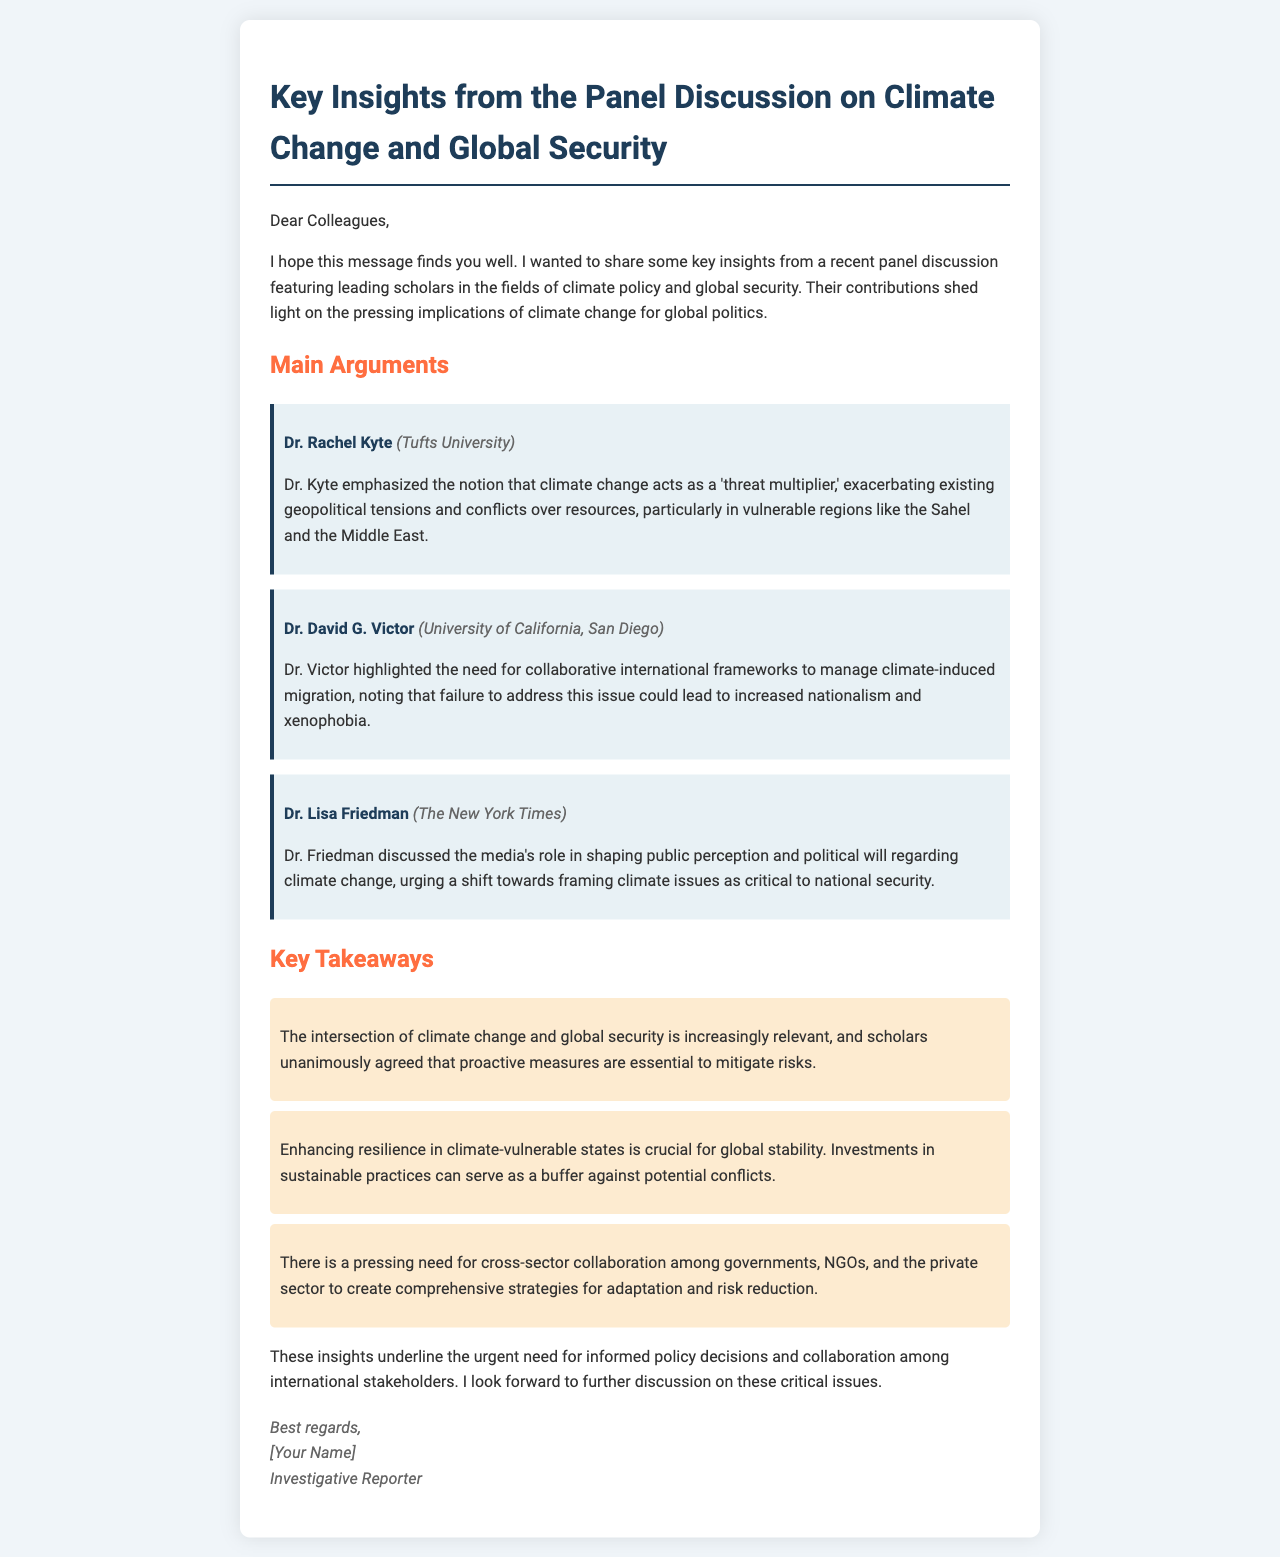What is the title of the panel discussion summary? The title is presented at the beginning of the email, summarizing the key insights from the discussion.
Answer: Key Insights from the Panel Discussion on Climate Change and Global Security Who is the first scholar mentioned in the email? The email lists the scholars in the main arguments section, starting with Dr. Rachel Kyte.
Answer: Dr. Rachel Kyte What is the institution affiliated with Dr. David G. Victor? The email provides the institutions of the scholars, specifically noting University of California, San Diego for Dr. Victor.
Answer: University of California, San Diego What term did Dr. Kyte use to describe the impact of climate change on geopolitics? Dr. Kyte described climate change as a 'threat multiplier' affecting geopolitical tensions.
Answer: threat multiplier Which sector did Dr. Friedman emphasize for framing climate issues? Dr. Friedman highlighted the media's role in shaping public perception regarding climate change in the context of national security.
Answer: media What is the pressing need highlighted by the scholars for managing climate-induced migration? The panel highlighted the need for collaborative international frameworks to address migration issues stemming from climate change.
Answer: collaborative international frameworks How many key takeaways are mentioned in the email? The email lists a total of three key takeaways that summarize essential insights from the discussion.
Answer: three What is emphasized as crucial for global stability in the key takeaways? One of the key takeaways stresses the importance of enhancing resilience in climate-vulnerable states for maintaining global stability.
Answer: enhancing resilience What is the profession of the person sending the email? The sender identifies their role at the end of the email, specifying their profession.
Answer: Investigative Reporter 